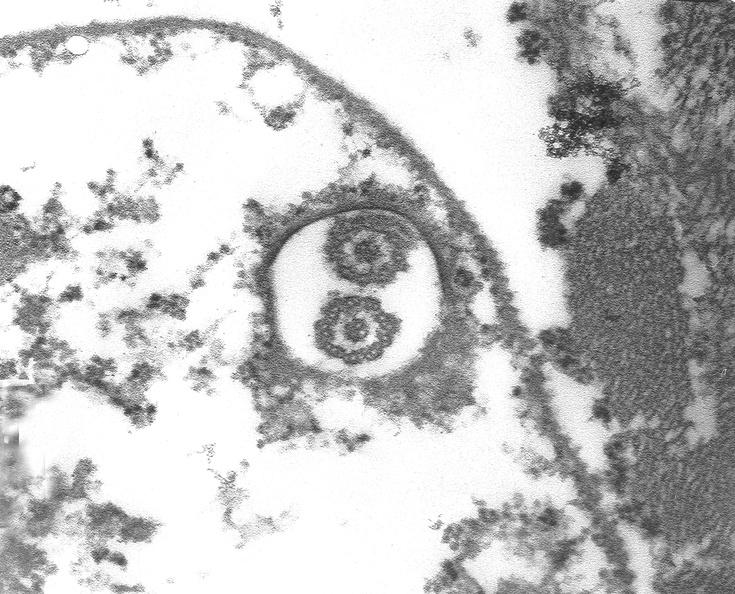s amyloidosis present?
Answer the question using a single word or phrase. No 